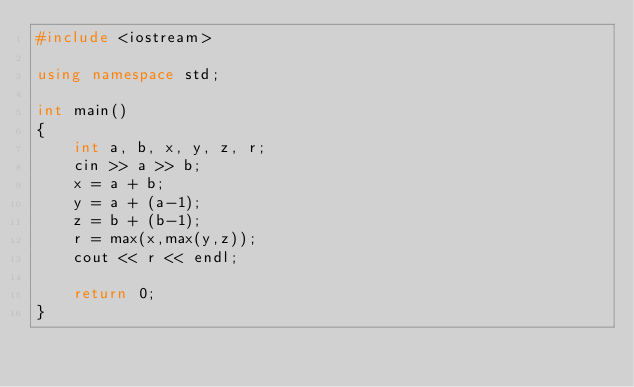<code> <loc_0><loc_0><loc_500><loc_500><_C++_>#include <iostream>

using namespace std;

int main()
{
    int a, b, x, y, z, r;
    cin >> a >> b;
    x = a + b;
    y = a + (a-1);
    z = b + (b-1);
    r = max(x,max(y,z));
    cout << r << endl;

    return 0;
}</code> 